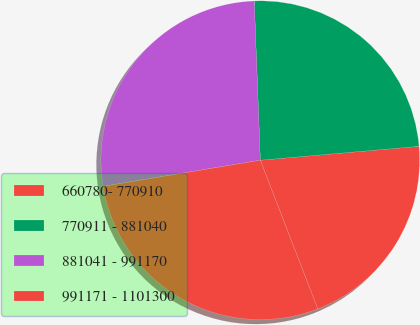Convert chart. <chart><loc_0><loc_0><loc_500><loc_500><pie_chart><fcel>660780- 770910<fcel>770911 - 881040<fcel>881041 - 991170<fcel>991171 - 1101300<nl><fcel>20.52%<fcel>24.22%<fcel>27.01%<fcel>28.24%<nl></chart> 